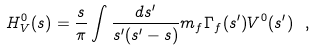Convert formula to latex. <formula><loc_0><loc_0><loc_500><loc_500>H ^ { 0 } _ { V } ( s ) = \frac { s } { \pi } \int \frac { d s ^ { \prime } } { s ^ { \prime } ( s ^ { \prime } - s ) } m _ { f } \Gamma _ { f } ( s ^ { \prime } ) V ^ { 0 } ( s ^ { \prime } ) \ ,</formula> 